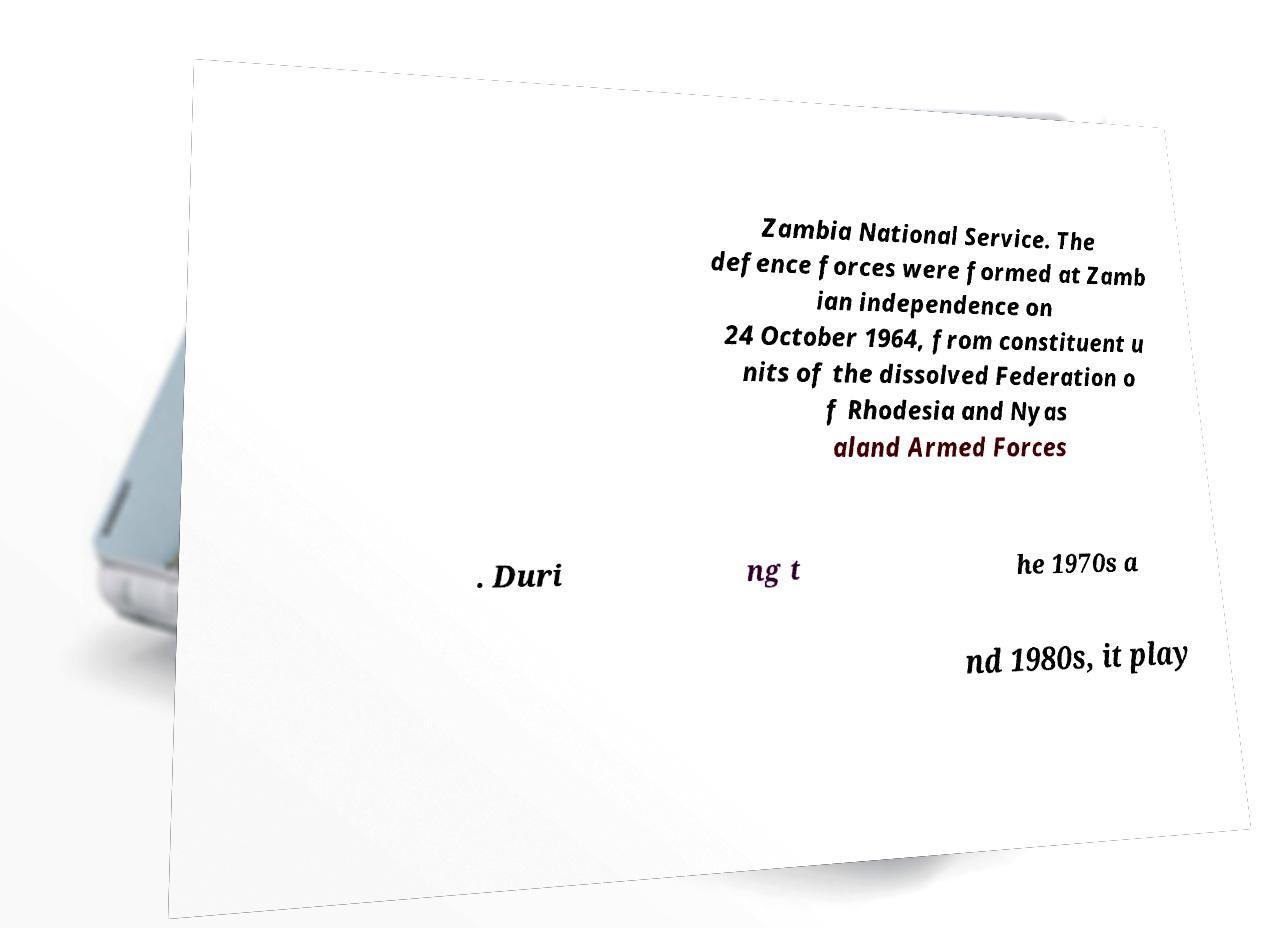Could you assist in decoding the text presented in this image and type it out clearly? Zambia National Service. The defence forces were formed at Zamb ian independence on 24 October 1964, from constituent u nits of the dissolved Federation o f Rhodesia and Nyas aland Armed Forces . Duri ng t he 1970s a nd 1980s, it play 